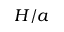<formula> <loc_0><loc_0><loc_500><loc_500>H / a</formula> 